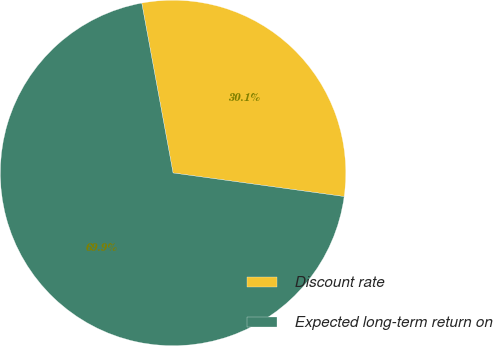<chart> <loc_0><loc_0><loc_500><loc_500><pie_chart><fcel>Discount rate<fcel>Expected long-term return on<nl><fcel>30.08%<fcel>69.92%<nl></chart> 